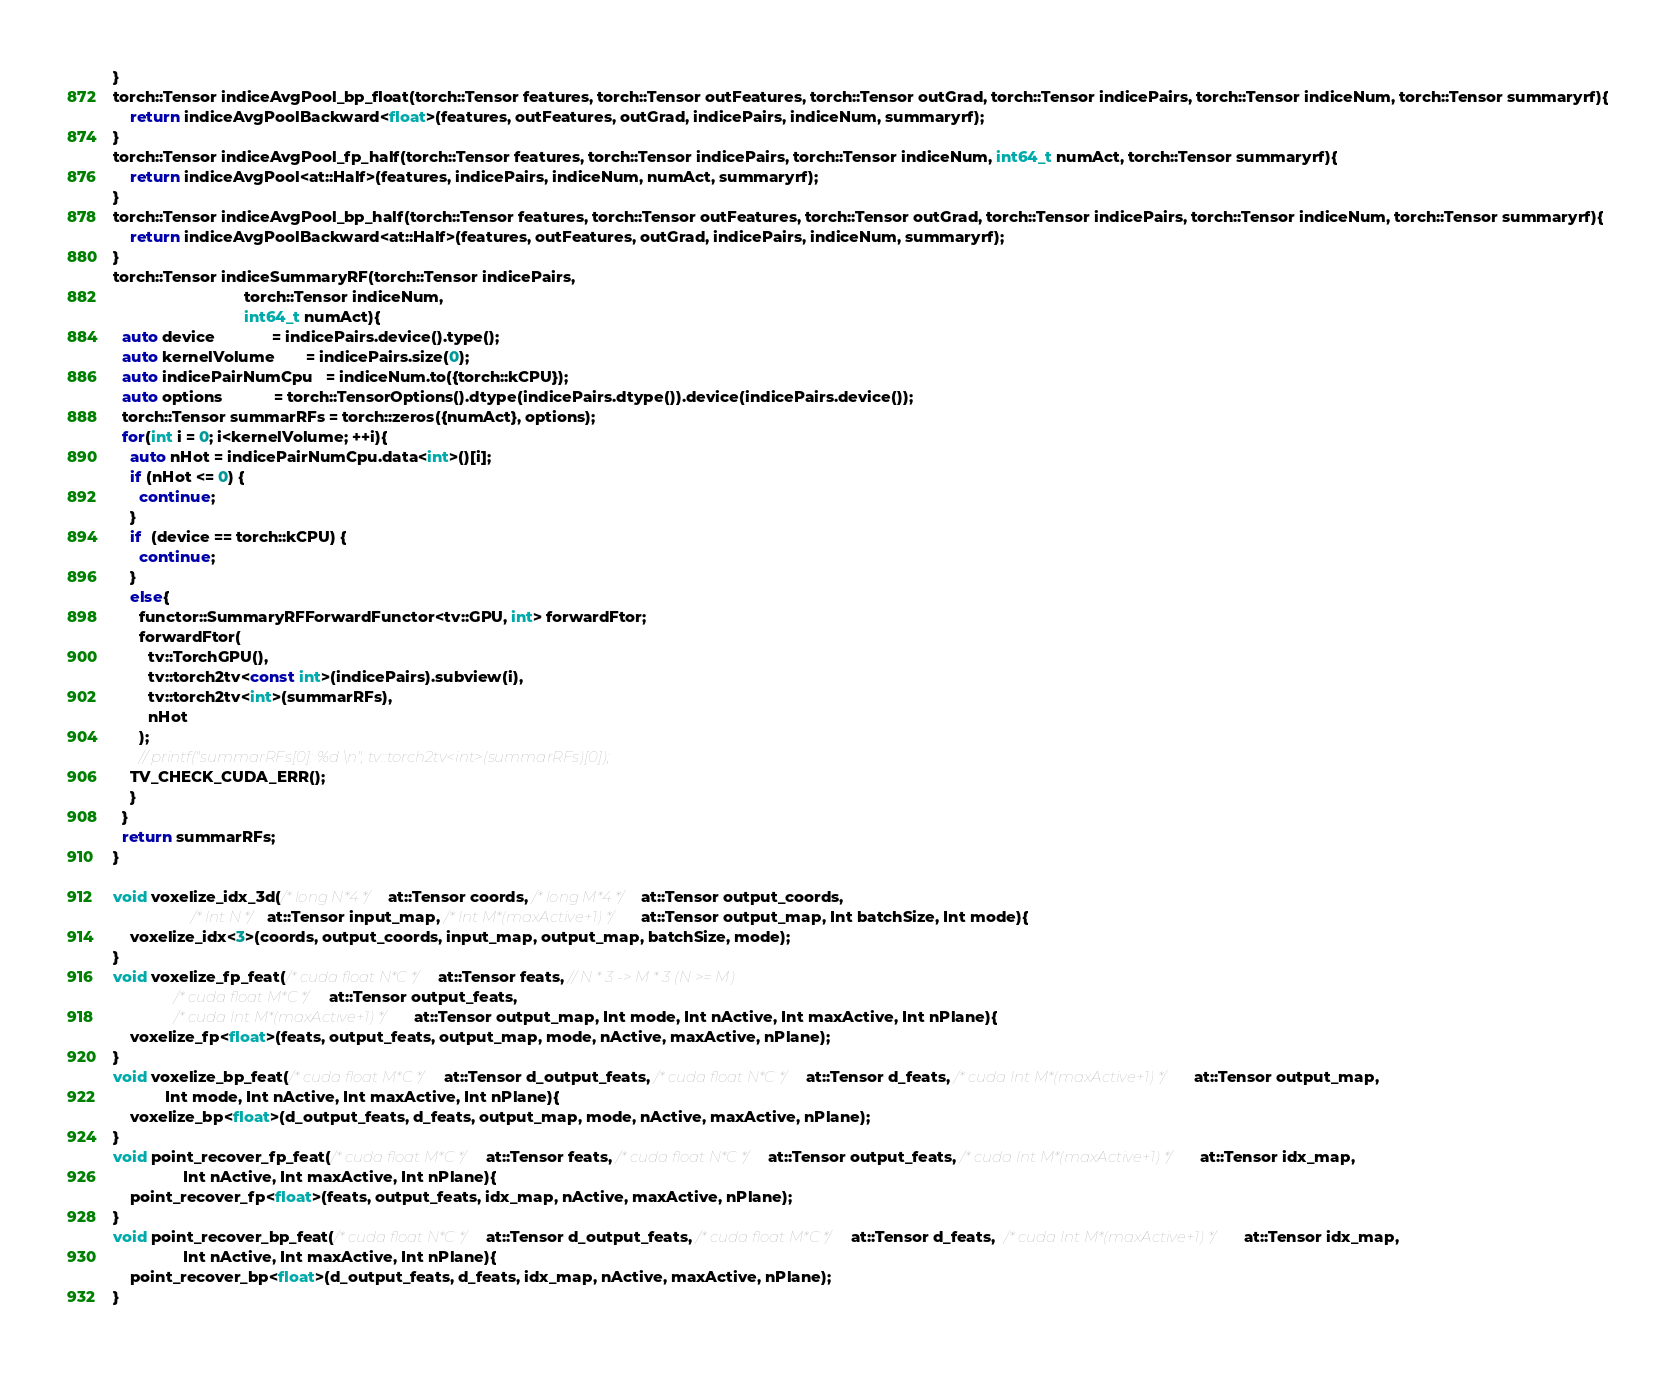Convert code to text. <code><loc_0><loc_0><loc_500><loc_500><_Cuda_>}
torch::Tensor indiceAvgPool_bp_float(torch::Tensor features, torch::Tensor outFeatures, torch::Tensor outGrad, torch::Tensor indicePairs, torch::Tensor indiceNum, torch::Tensor summaryrf){
    return indiceAvgPoolBackward<float>(features, outFeatures, outGrad, indicePairs, indiceNum, summaryrf);
}
torch::Tensor indiceAvgPool_fp_half(torch::Tensor features, torch::Tensor indicePairs, torch::Tensor indiceNum, int64_t numAct, torch::Tensor summaryrf){
    return indiceAvgPool<at::Half>(features, indicePairs, indiceNum, numAct, summaryrf);
}
torch::Tensor indiceAvgPool_bp_half(torch::Tensor features, torch::Tensor outFeatures, torch::Tensor outGrad, torch::Tensor indicePairs, torch::Tensor indiceNum, torch::Tensor summaryrf){
    return indiceAvgPoolBackward<at::Half>(features, outFeatures, outGrad, indicePairs, indiceNum, summaryrf);
}
torch::Tensor indiceSummaryRF(torch::Tensor indicePairs,
                              torch::Tensor indiceNum, 
                              int64_t numAct){
  auto device             = indicePairs.device().type();
  auto kernelVolume       = indicePairs.size(0);
  auto indicePairNumCpu   = indiceNum.to({torch::kCPU});
  auto options            = torch::TensorOptions().dtype(indicePairs.dtype()).device(indicePairs.device());
  torch::Tensor summarRFs = torch::zeros({numAct}, options);
  for(int i = 0; i<kernelVolume; ++i){
    auto nHot = indicePairNumCpu.data<int>()[i];
    if (nHot <= 0) {
      continue;
    }
    if  (device == torch::kCPU) {
      continue;
    }
    else{
      functor::SummaryRFForwardFunctor<tv::GPU, int> forwardFtor;
      forwardFtor(
        tv::TorchGPU(),
        tv::torch2tv<const int>(indicePairs).subview(i),
        tv::torch2tv<int>(summarRFs),
        nHot
      );
      // printf("summarRFs[0]: %d \n", tv::torch2tv<int>(summarRFs)[0]);
    TV_CHECK_CUDA_ERR();
    }
  }
  return summarRFs;
}

void voxelize_idx_3d(/* long N*4 */ at::Tensor coords, /* long M*4 */ at::Tensor output_coords,
                  /* Int N */ at::Tensor input_map, /* Int M*(maxActive+1) */ at::Tensor output_map, Int batchSize, Int mode){
    voxelize_idx<3>(coords, output_coords, input_map, output_map, batchSize, mode);
}
void voxelize_fp_feat(/* cuda float N*C */ at::Tensor feats, // N * 3 -> M * 3 (N >= M)
              /* cuda float M*C */ at::Tensor output_feats,
              /* cuda Int M*(maxActive+1) */ at::Tensor output_map, Int mode, Int nActive, Int maxActive, Int nPlane){
    voxelize_fp<float>(feats, output_feats, output_map, mode, nActive, maxActive, nPlane);
}
void voxelize_bp_feat(/* cuda float M*C */ at::Tensor d_output_feats, /* cuda float N*C */ at::Tensor d_feats, /* cuda Int M*(maxActive+1) */ at::Tensor output_map,
            Int mode, Int nActive, Int maxActive, Int nPlane){
    voxelize_bp<float>(d_output_feats, d_feats, output_map, mode, nActive, maxActive, nPlane);
}
void point_recover_fp_feat(/* cuda float M*C */ at::Tensor feats, /* cuda float N*C */ at::Tensor output_feats, /* cuda Int M*(maxActive+1) */ at::Tensor idx_map,
                Int nActive, Int maxActive, Int nPlane){
    point_recover_fp<float>(feats, output_feats, idx_map, nActive, maxActive, nPlane);
}
void point_recover_bp_feat(/* cuda float N*C */ at::Tensor d_output_feats, /* cuda float M*C */ at::Tensor d_feats,  /* cuda Int M*(maxActive+1) */ at::Tensor idx_map,
                Int nActive, Int maxActive, Int nPlane){
    point_recover_bp<float>(d_output_feats, d_feats, idx_map, nActive, maxActive, nPlane);
}

</code> 